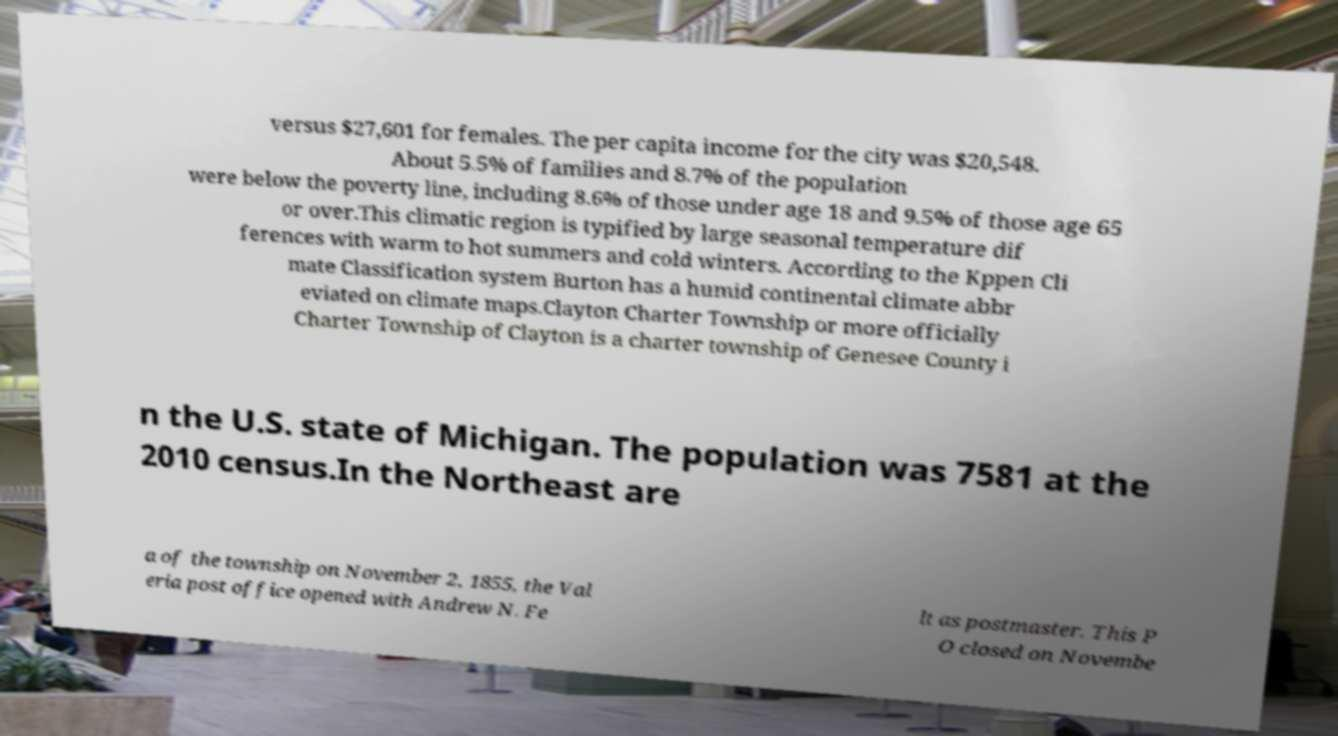Please read and relay the text visible in this image. What does it say? versus $27,601 for females. The per capita income for the city was $20,548. About 5.5% of families and 8.7% of the population were below the poverty line, including 8.6% of those under age 18 and 9.5% of those age 65 or over.This climatic region is typified by large seasonal temperature dif ferences with warm to hot summers and cold winters. According to the Kppen Cli mate Classification system Burton has a humid continental climate abbr eviated on climate maps.Clayton Charter Township or more officially Charter Township of Clayton is a charter township of Genesee County i n the U.S. state of Michigan. The population was 7581 at the 2010 census.In the Northeast are a of the township on November 2, 1855, the Val eria post office opened with Andrew N. Fe lt as postmaster. This P O closed on Novembe 